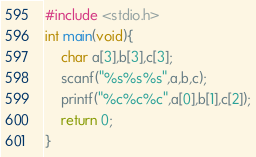<code> <loc_0><loc_0><loc_500><loc_500><_C_>#include <stdio.h>
int main(void){
    char a[3],b[3],c[3];
    scanf("%s%s%s",a,b,c);
    printf("%c%c%c",a[0],b[1],c[2]);
    return 0;
}</code> 